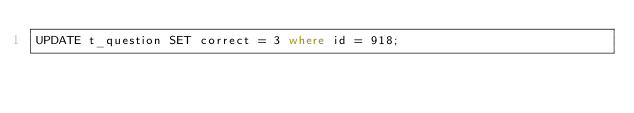<code> <loc_0><loc_0><loc_500><loc_500><_SQL_>UPDATE t_question SET correct = 3 where id = 918;</code> 